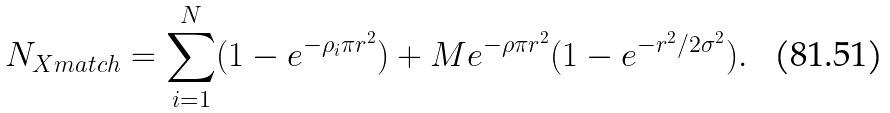Convert formula to latex. <formula><loc_0><loc_0><loc_500><loc_500>N _ { X m a t c h } = \sum _ { i = 1 } ^ { N } ( 1 - e ^ { - \rho _ { i } \pi r ^ { 2 } } ) + M e ^ { - \rho \pi r ^ { 2 } } ( 1 - e ^ { - r ^ { 2 } / 2 \sigma ^ { 2 } } ) .</formula> 